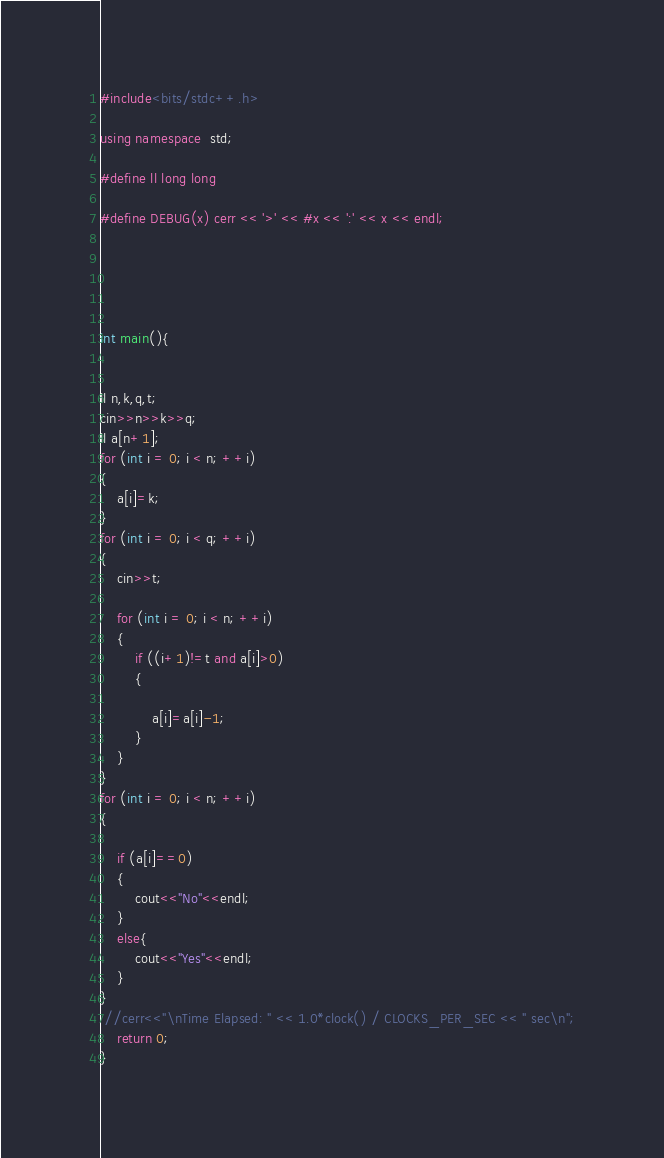Convert code to text. <code><loc_0><loc_0><loc_500><loc_500><_C++_>#include<bits/stdc++.h>

using namespace  std;

#define ll long long

#define DEBUG(x) cerr << '>' << #x << ':' << x << endl;





int main(){
    
  
ll n,k,q,t;
cin>>n>>k>>q;
ll a[n+1];
for (int i = 0; i < n; ++i)
{
    a[i]=k;
}
for (int i = 0; i < q; ++i)
{
    cin>>t;

    for (int i = 0; i < n; ++i)
    {
        if ((i+1)!=t and a[i]>0)
        {

            a[i]=a[i]-1;
        }
    }
}
for (int i = 0; i < n; ++i)
{

    if (a[i]==0)
    {
        cout<<"No"<<endl;
    }
    else{
        cout<<"Yes"<<endl;
    }
}
 //cerr<<"\nTime Elapsed: " << 1.0*clock() / CLOCKS_PER_SEC << " sec\n";
    return 0;
} </code> 